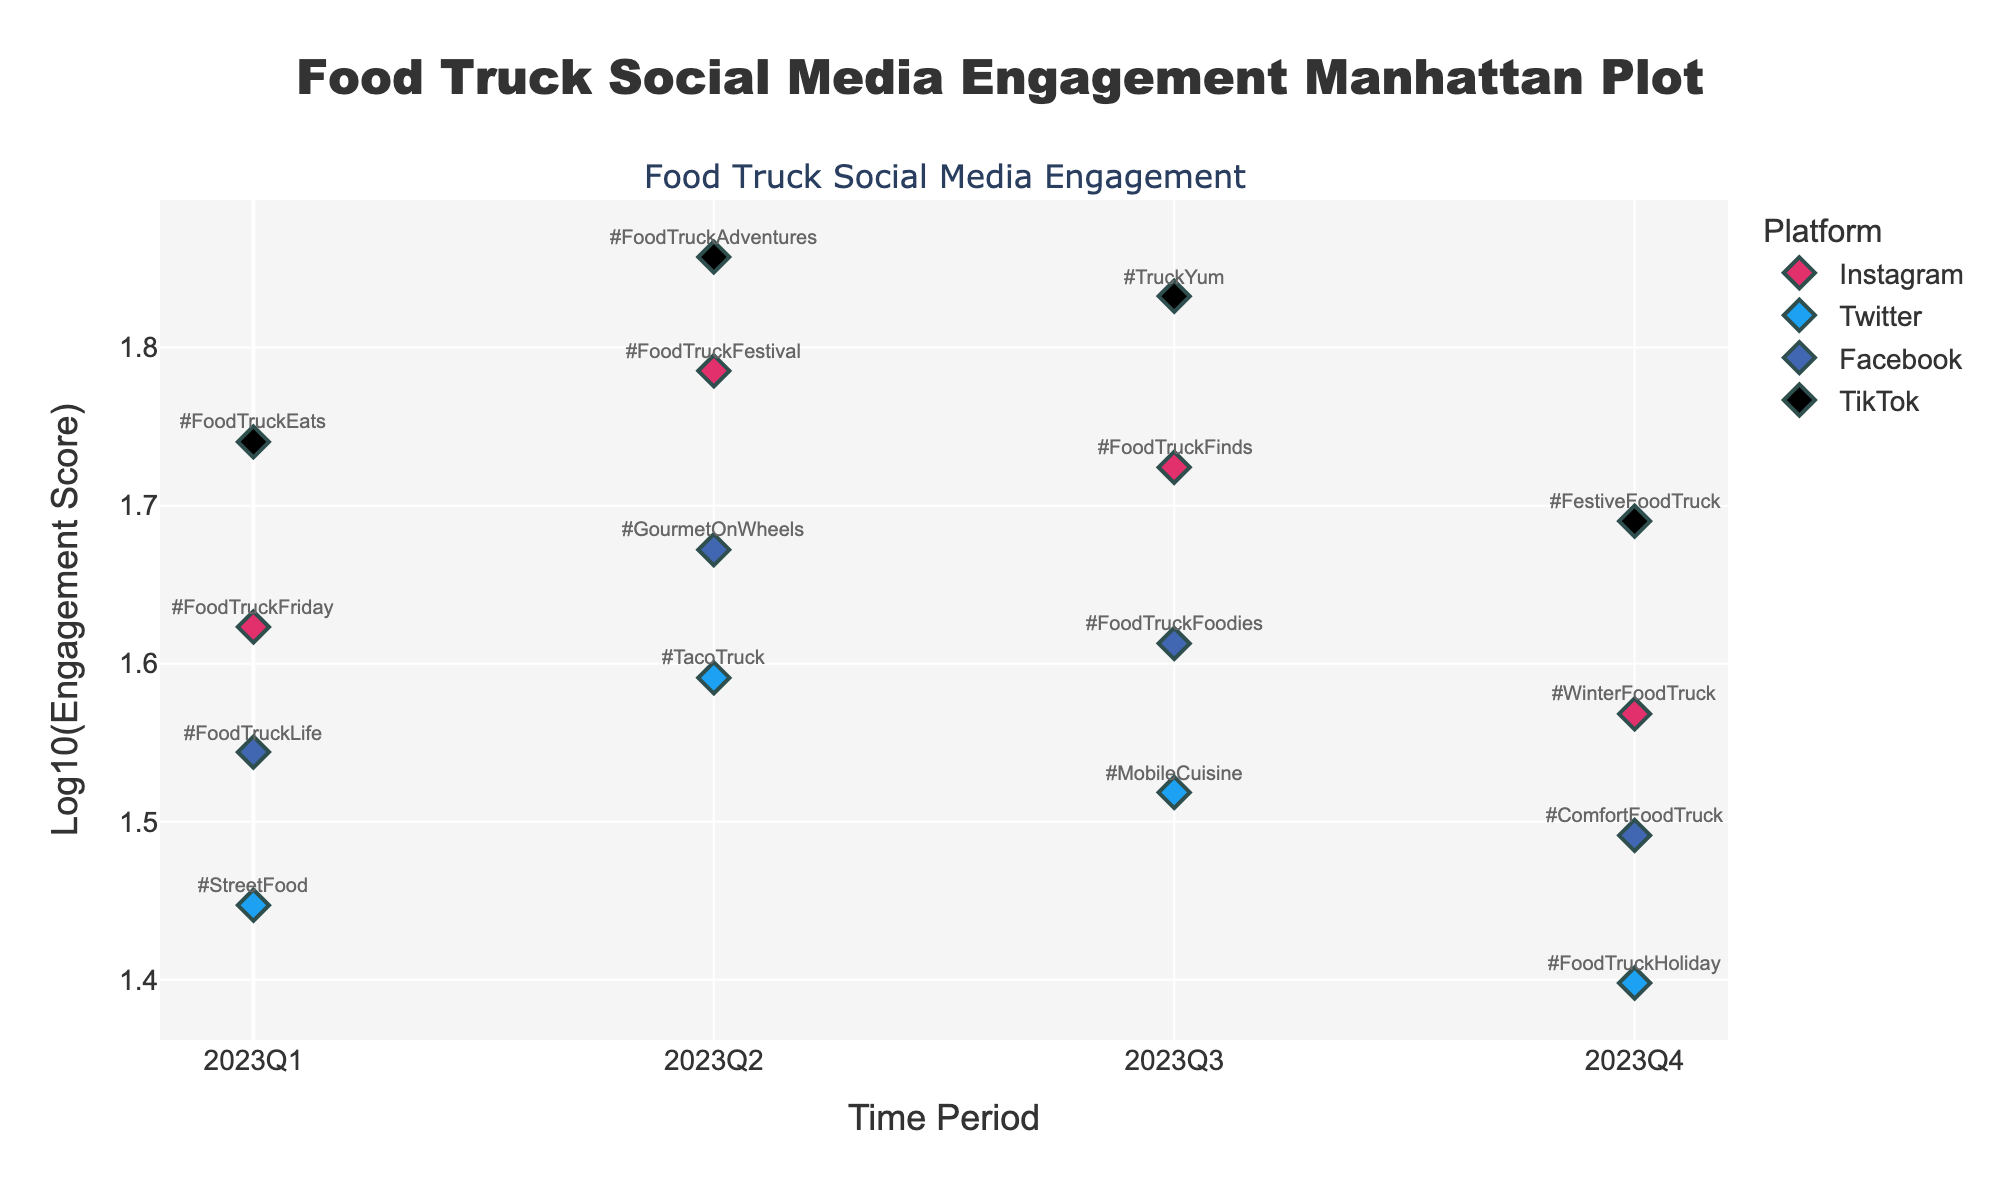What is the overall engagement trend for TikTok posts across different time periods? To analyze the engagement trend for TikTok posts, look at the log-scaled engagement scores for TikTok across all time periods. Notice that the log engagement scores for TikTok increase from 2023Q1 to 2023Q3, then slightly decrease in 2023Q4. This indicates a general upward trend in engagement, peaking in 2023Q3.
Answer: Increasing, peaking in 2023Q3 Which platform had the highest engagement score in 2023Q2? Look at the points corresponding to 2023Q2 in the Manhattan Plot and compare the heights of the markers. The highest log-scaled engagement score for 2023Q2 corresponds to TikTok, indicated by the highest point. The exact hashtag is #FoodTruckAdventures.
Answer: TikTok How does the engagement for Instagram in 2023Q3 compare to TikTok in the same period? Locate the points for 2023Q3 for both Instagram and TikTok. Compare the heights of the points; Instagram's engagement score is lower than TikTok's in this period, as TikTok's marker is higher on the log scale.
Answer: Lower What is the difference in engagement scores between the highest and lowest performing hashtags in 2023Q4? Identify the marker with the highest log-scaled engagement score in 2023Q4 (TikTok: #FestiveFoodTruck) and the marker with the lowest score (Twitter: #FoodTruckHoliday). Convert these log scores back to engagement scores and subtract the lowest from the highest.
Answer: 24 (49 - 25) Which time period had the most consistent engagement across all platforms? To answer this, look at the spread of log-scaled engagement scores within each time period and determine which period has the least variation. 2023Q1 has the smallest spread between the highest (TikTok: 55) and the lowest engagement scores (Twitter: 28), showing more consistency.
Answer: 2023Q1 